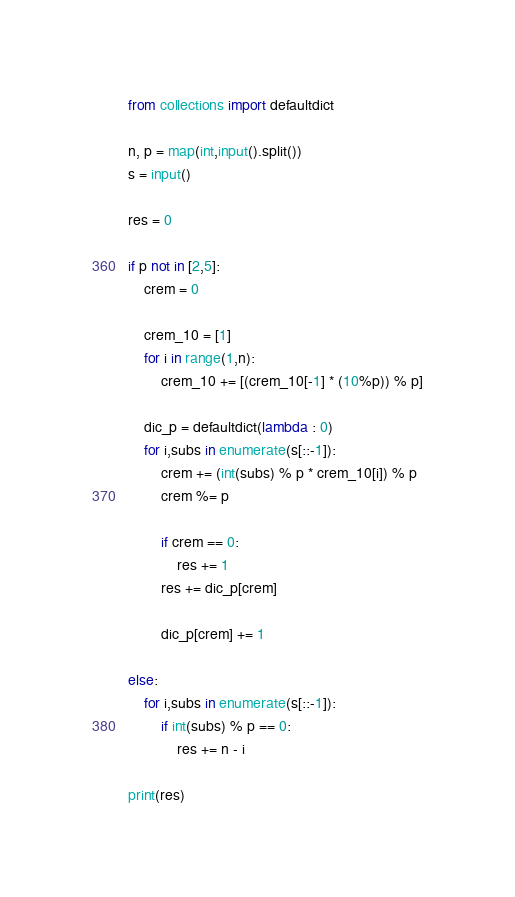Convert code to text. <code><loc_0><loc_0><loc_500><loc_500><_Python_>from collections import defaultdict

n, p = map(int,input().split())
s = input()

res = 0

if p not in [2,5]:
    crem = 0
    
    crem_10 = [1]
    for i in range(1,n):
        crem_10 += [(crem_10[-1] * (10%p)) % p]
        
    dic_p = defaultdict(lambda : 0)
    for i,subs in enumerate(s[::-1]):
        crem += (int(subs) % p * crem_10[i]) % p
        crem %= p

        if crem == 0:
            res += 1
        res += dic_p[crem]

        dic_p[crem] += 1
        
else:
    for i,subs in enumerate(s[::-1]):
        if int(subs) % p == 0:
            res += n - i
    
print(res)</code> 